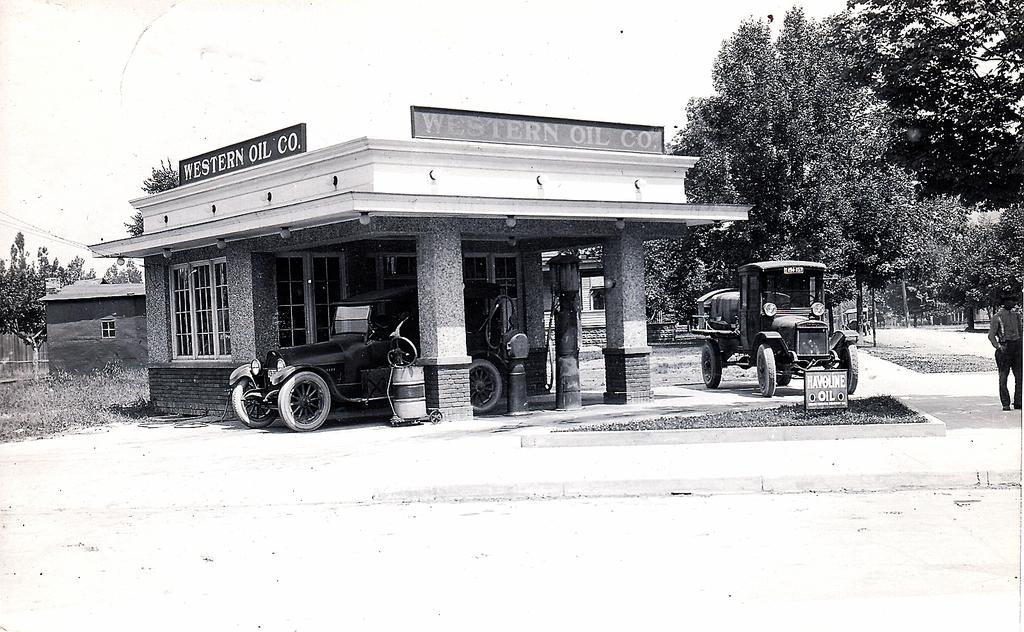Could you give a brief overview of what you see in this image? This is a black and white image in this image in the center there are some houses, trees, vehicles and some persons. At the bottom there is sand grass, and at the top of the image there is sky. 